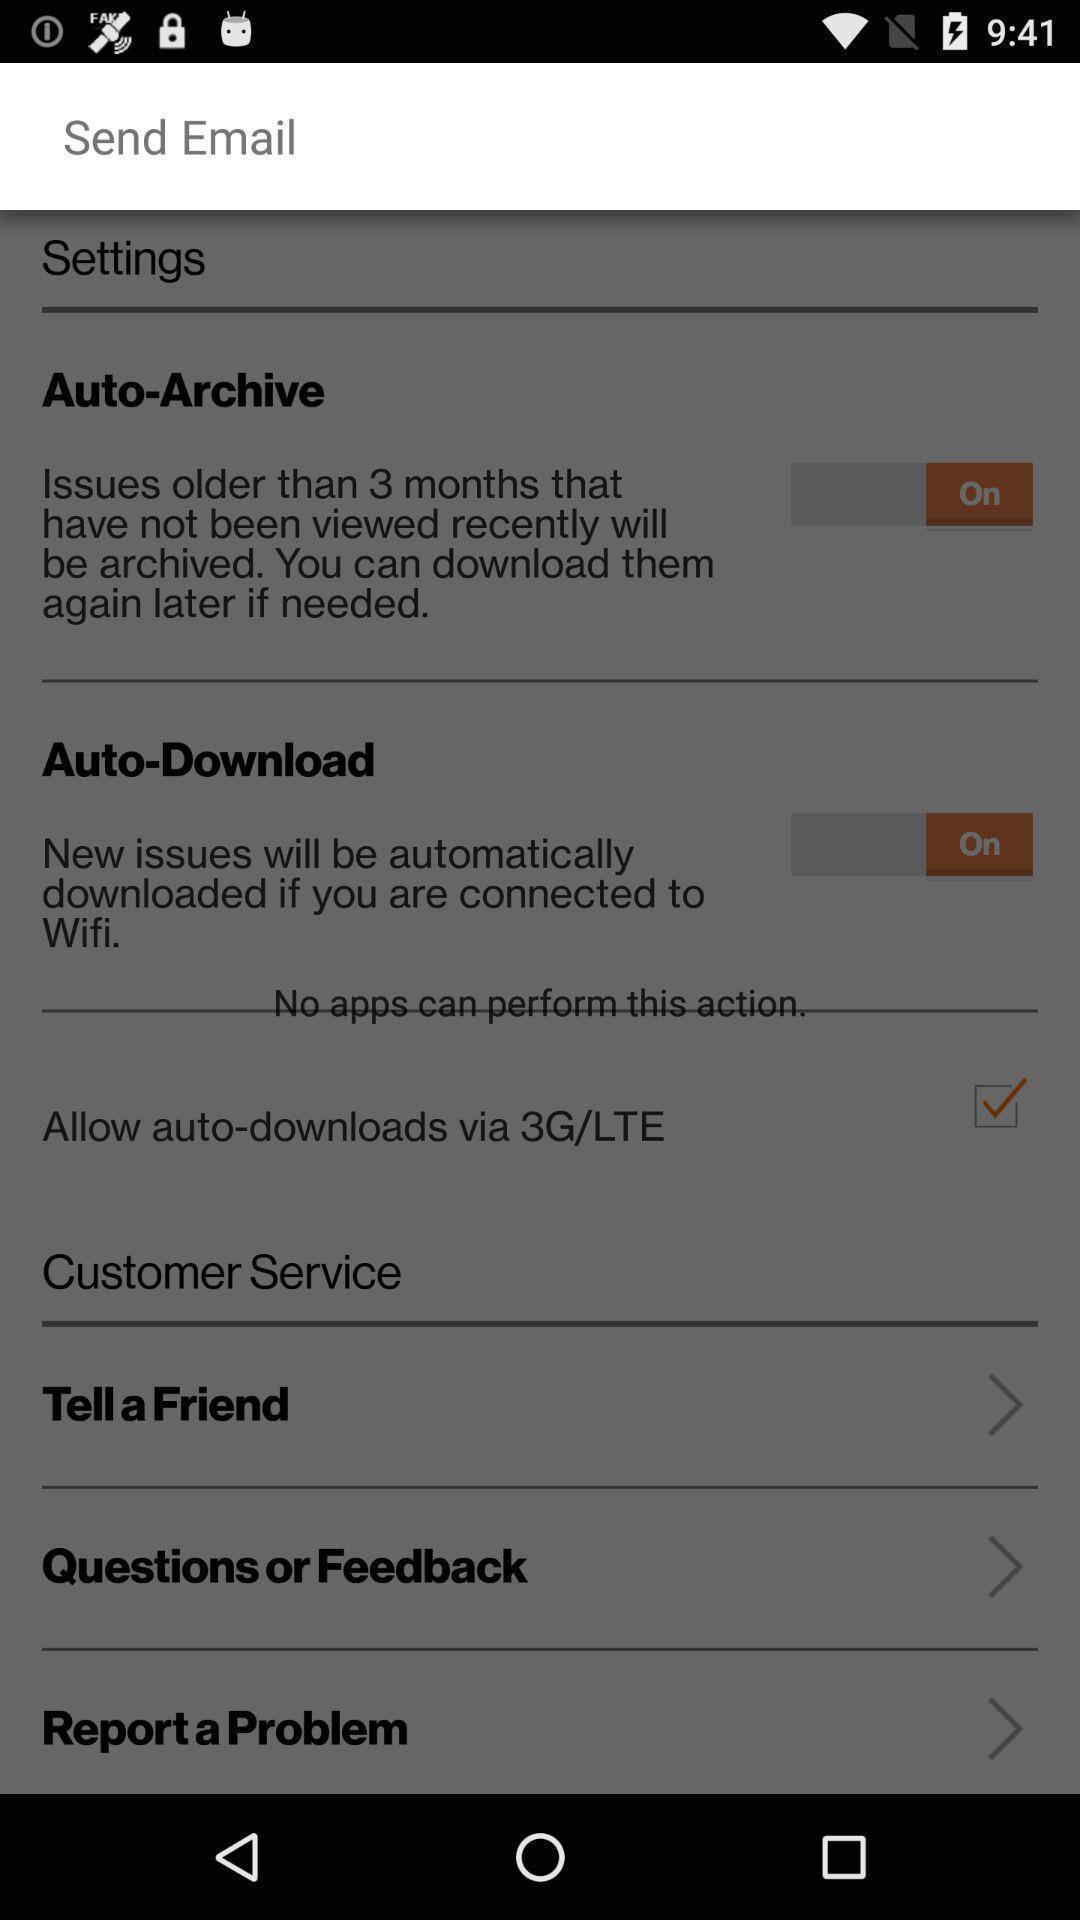Describe the content in this image. Screen showing send email. 